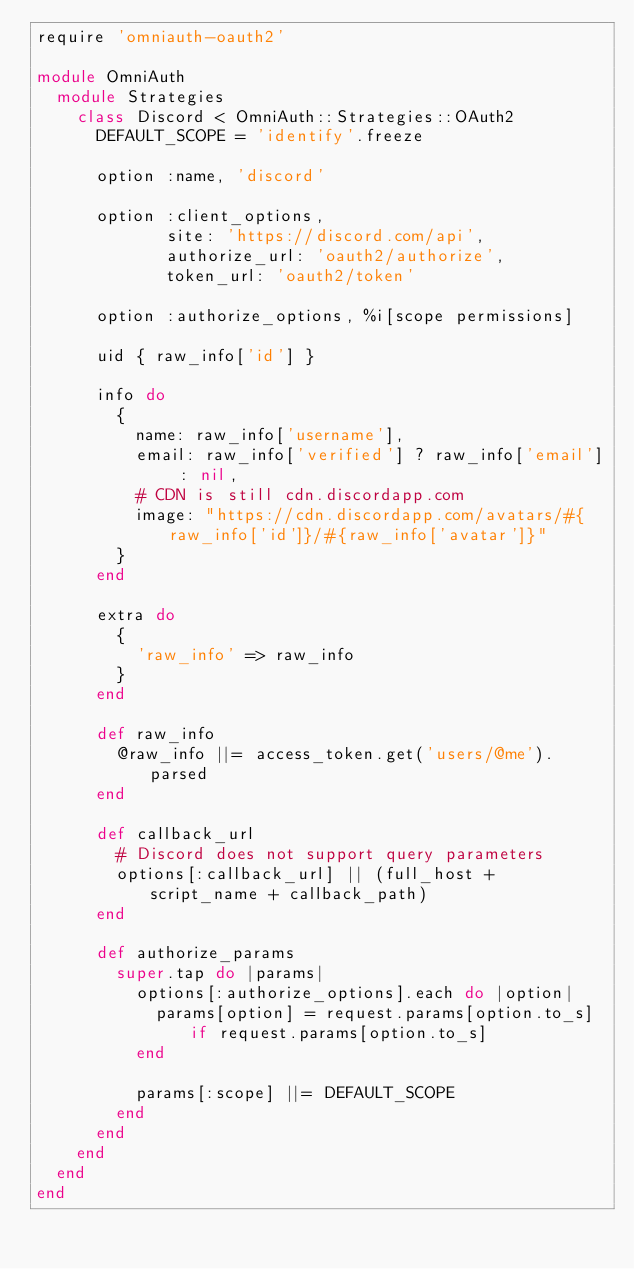Convert code to text. <code><loc_0><loc_0><loc_500><loc_500><_Ruby_>require 'omniauth-oauth2'

module OmniAuth
  module Strategies
    class Discord < OmniAuth::Strategies::OAuth2
      DEFAULT_SCOPE = 'identify'.freeze

      option :name, 'discord'

      option :client_options,
             site: 'https://discord.com/api',
             authorize_url: 'oauth2/authorize',
             token_url: 'oauth2/token'

      option :authorize_options, %i[scope permissions]

      uid { raw_info['id'] }

      info do
        {
          name: raw_info['username'],
          email: raw_info['verified'] ? raw_info['email'] : nil,
          # CDN is still cdn.discordapp.com
          image: "https://cdn.discordapp.com/avatars/#{raw_info['id']}/#{raw_info['avatar']}"
        }
      end

      extra do
        {
          'raw_info' => raw_info
        }
      end

      def raw_info
        @raw_info ||= access_token.get('users/@me').parsed
      end

      def callback_url
        # Discord does not support query parameters
        options[:callback_url] || (full_host + script_name + callback_path)
      end

      def authorize_params
        super.tap do |params|
          options[:authorize_options].each do |option|
            params[option] = request.params[option.to_s] if request.params[option.to_s]
          end

          params[:scope] ||= DEFAULT_SCOPE
        end
      end
    end
  end
end
</code> 